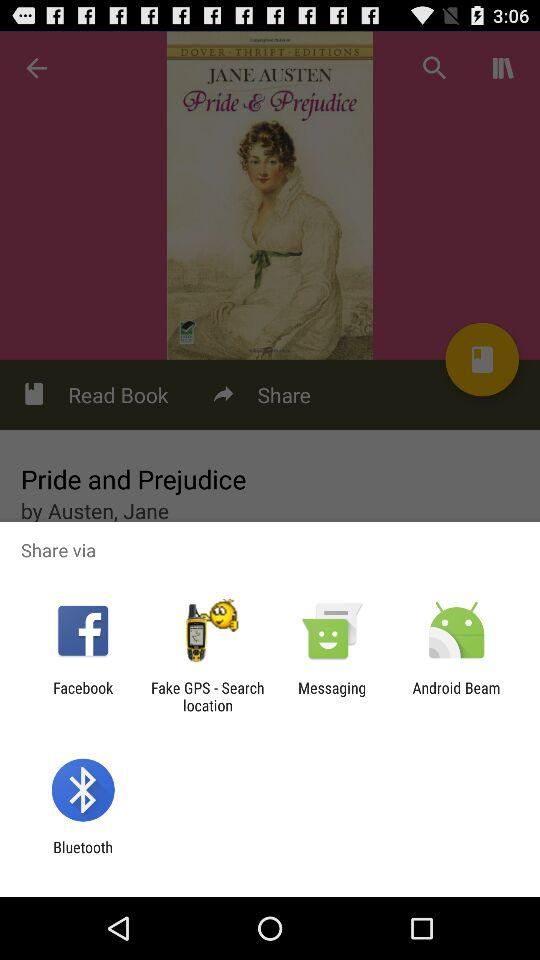Through which apps can we share? The apps are "Facebook", "Fake GPS - Search location", "Messaging", "Android Beam" and "Bluetooth". 